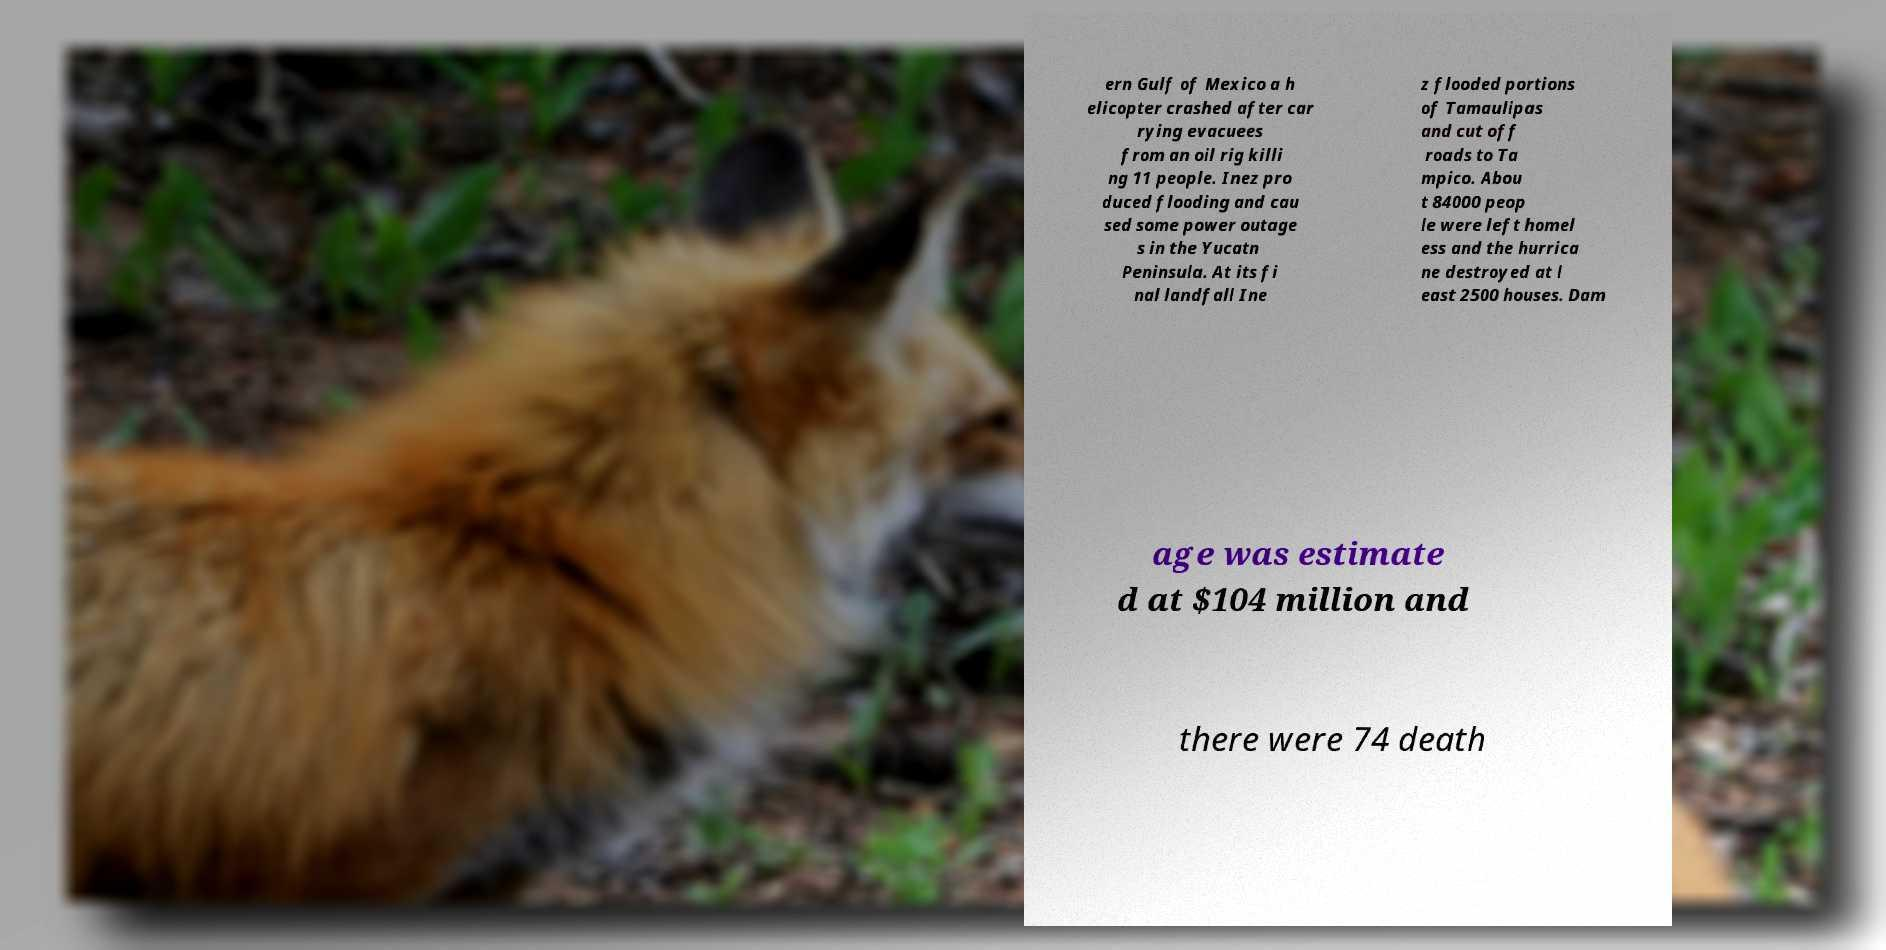What messages or text are displayed in this image? I need them in a readable, typed format. ern Gulf of Mexico a h elicopter crashed after car rying evacuees from an oil rig killi ng 11 people. Inez pro duced flooding and cau sed some power outage s in the Yucatn Peninsula. At its fi nal landfall Ine z flooded portions of Tamaulipas and cut off roads to Ta mpico. Abou t 84000 peop le were left homel ess and the hurrica ne destroyed at l east 2500 houses. Dam age was estimate d at $104 million and there were 74 death 